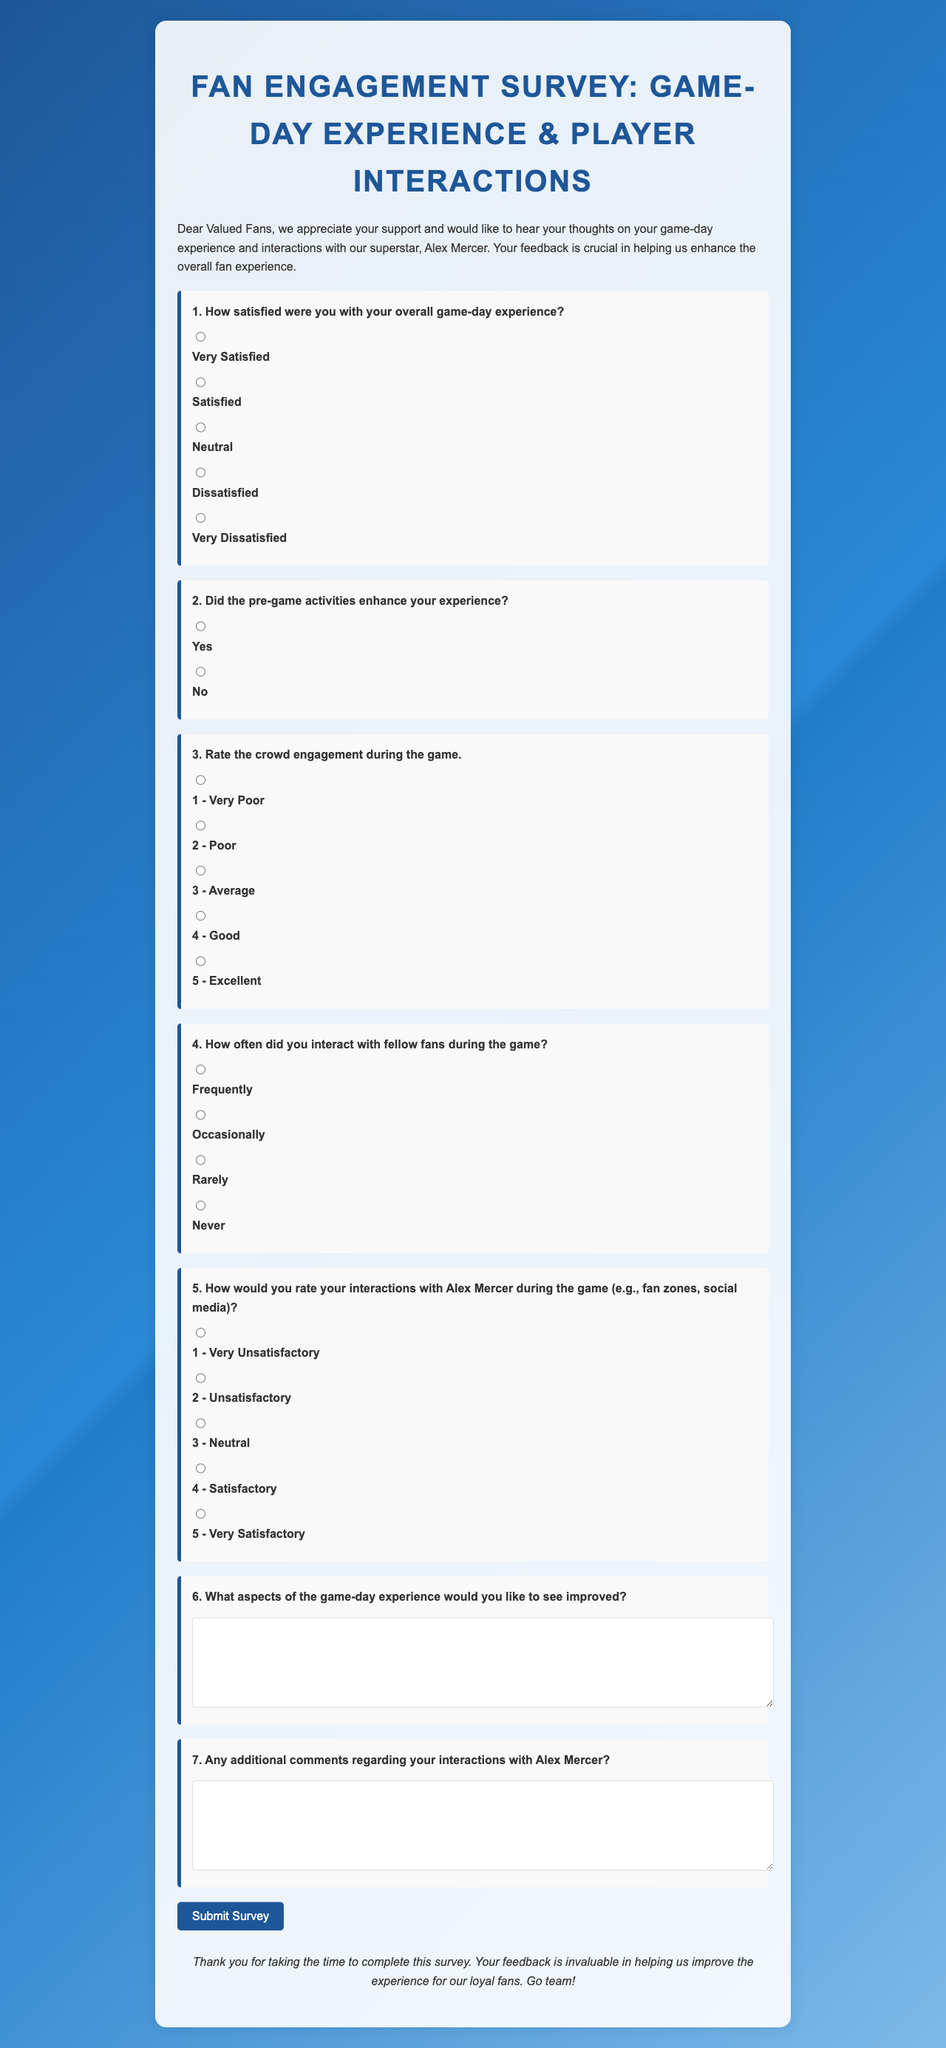What is the title of the document? The title of the document is specified in the <title> tag, which is "Fan Engagement Survey".
Answer: Fan Engagement Survey Who is the superstar mentioned in the survey? The superstar referred to in the survey is mentioned in the introduction, identifying him as "Alex Mercer".
Answer: Alex Mercer How many questions are there in the survey? The total number of questions is counted from the numbered list provided in the document, which includes seven specific questions.
Answer: 7 What is the first option for question one about satisfaction? The first option for satisfaction is detailed as "Very Satisfied" under question one.
Answer: Very Satisfied What aspect of the game-day experience can fans suggest to improve? Fans are given a space to provide feedback on any part of the game-day experience they would like to see improved, specified in question six.
Answer: Game-day experience What kind of feedback does the survey seek regarding interactions with Alex Mercer? The document indicates that the survey seeks any additional comments specifically about interactions with Alex Mercer in question seven.
Answer: Additional comments What is the primary goal of the survey? The primary goal is stated in the introduction, emphasizing the importance of feedback to enhance the overall fan experience.
Answer: Enhance overall fan experience 